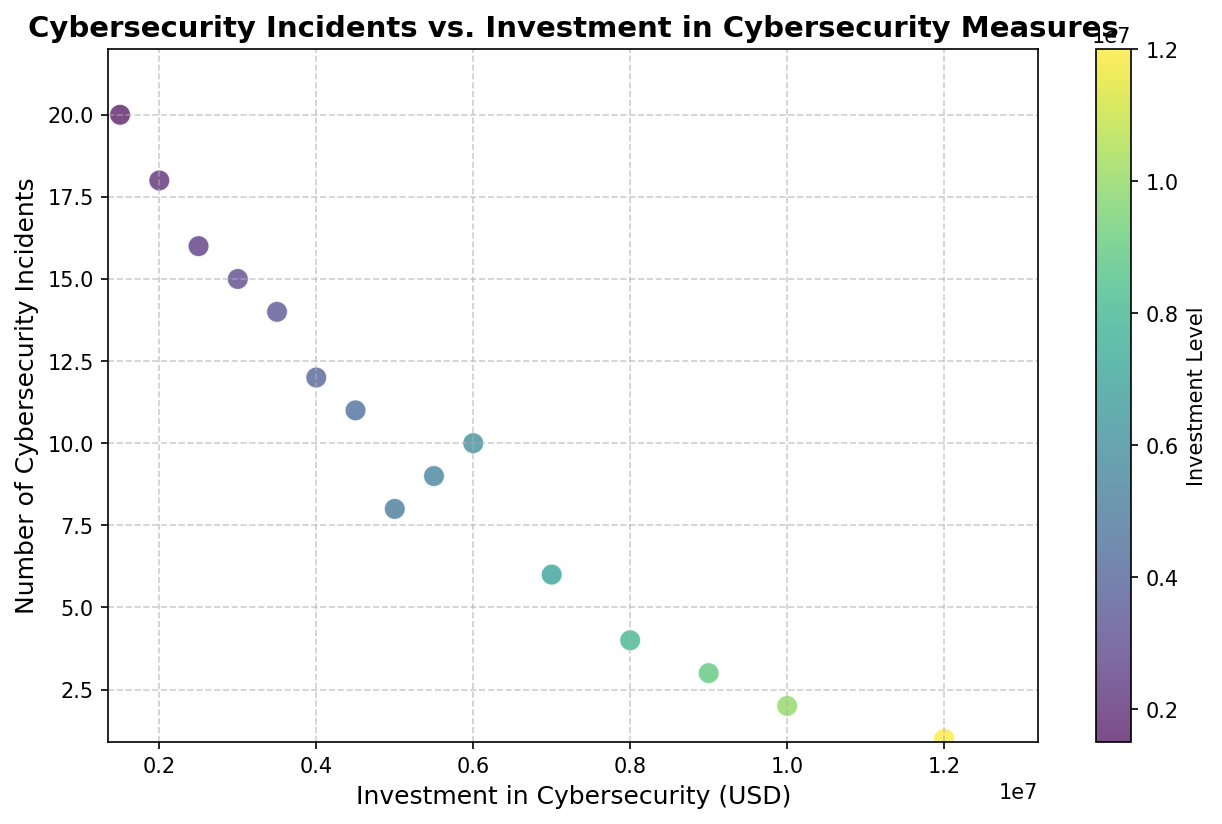What is the general trend between cybersecurity investment and the number of resulting incidents? The scatter plot demonstrates a general trend: companies that invest more in cybersecurity measures tend to report fewer cybersecurity incidents. This is indicated by the downward slope from left (higher incidents, lower investment) to right (lower incidents, higher investment).
Answer: Inverse relationship Which company has the highest investment in cybersecurity and how many incidents did they experience? FortressIT has the highest investment in cybersecurity at $12,000,000. They experienced only 1 cybersecurity incident, which is the lowest number among all companies.
Answer: FortressIT, 1 Compare the number of incidents for companies with the second highest and second lowest investments in cybersecurity. UltraSafe, with the second highest investment of $9,000,000, experienced 3 incidents, while InfoShield, with the second lowest investment of $1,500,000, experienced 20 incidents.
Answer: UltraSafe: 3, InfoShield: 20 Which company experienced the highest number of incidents, and what was their level of investment? InfoShield experienced the highest number of incidents at 20 and invested $1,500,000 in cybersecurity.
Answer: InfoShield, $1,500,000 What is the total investment in cybersecurity made by companies that experienced 10 or fewer incidents? Companies with 10 or fewer incidents include TechCorp, NetSecure, DataGuard, SecureByte, CyberDefend, UltraSafe, and FortressIT. Their investments total $5,000,000 + $8,000,000 + $6,000,000 + $7,000,000 + $10,000,000 + $9,000,000 + $12,000,000 = $57,000,000.
Answer: $57,000,000 Which company has an investment closest to the overall median investment among the listed companies, and how many incidents did they report? The investments in ascending order are $1,500,000, $2,000,000, $2,500,000, $3,000,000, $3,500,000, $4,000,000, $4,500,000, $5,000,000, $5,500,000, $6,000,000, $7,000,000, $8,000,000, $9,000,000, $10,000,000, and $12,000,000. The median investment is between $4,500,000 (ShieldTech) and $5,000,000 (TechCorp), each having 11 and 8 incidents respectively.
Answer: ShieldTech: 11, TechCorp: 8 How does the number of incidents for MaxSecure compare to DataGuard, and what are their respective investments? MaxSecure has 16 incidents and invested $2,500,000, while DataGuard has 10 incidents and invested $6,000,000. Comparatively, MaxSecure reports more incidents with lower investment than DataGuard.
Answer: MaxSecure: 16 incidents, $2,500,000; DataGuard: 10 incidents, $6,000,000 What investment amount marks the halfway point between the highest and lowest investments, and does any company have this exact investment? The highest investment is $12,000,000 (FortressIT) and the lowest is $1,500,000 (InfoShield). The midpoint is ($12,000,000 + $1,500,000)/2 = $6,750,000. No company has exactly this amount in the dataset.
Answer: $6,750,000; No company Which companies have an investment of more than $7,000,000 but fewer incidents than TechCorp? Companies with investments greater than $7,000,000 are NetSecure ($8,000,000), UltraSafe ($9,000,000), CyberDefend ($10,000,000), and FortressIT ($12,000,000). TechCorp reports 8 incidents. Comparing, UltraSafe (3), CyberDefend (2), and FortressIT (1) qualify as they have fewer than 8 incidents.
Answer: UltraSafe, CyberDefend, FortressIT 